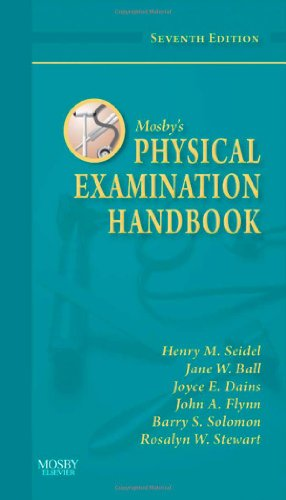Can you explain what topics are covered in this edition of the book? This edition covers a range of topics essential for effective physical examinations, including techniques for assessing organ systems, patient history taking, and special populations' examination. 